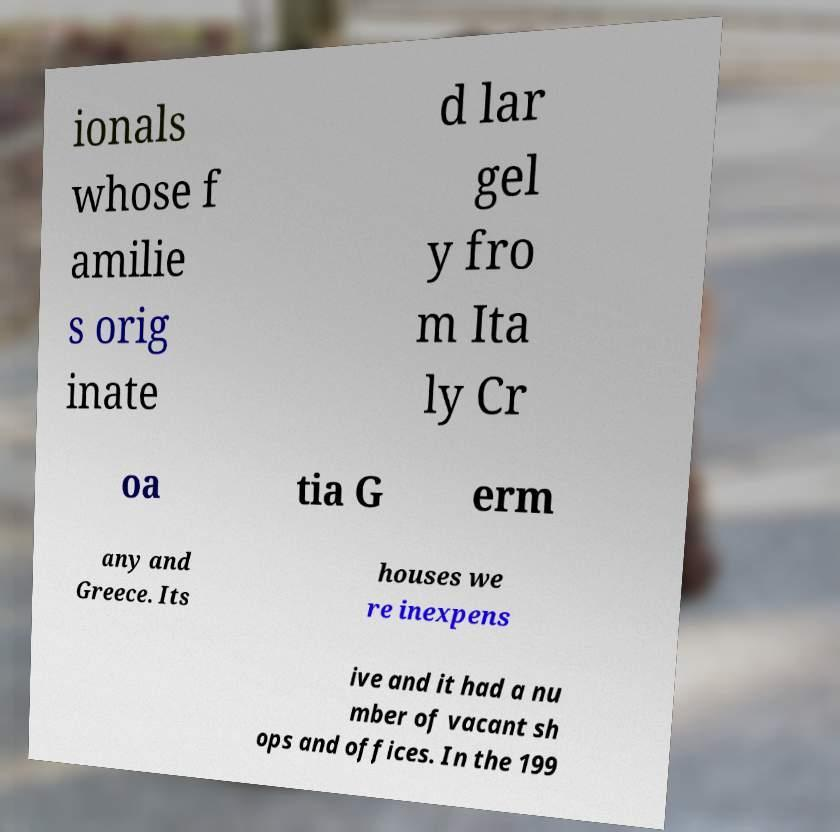Can you read and provide the text displayed in the image?This photo seems to have some interesting text. Can you extract and type it out for me? ionals whose f amilie s orig inate d lar gel y fro m Ita ly Cr oa tia G erm any and Greece. Its houses we re inexpens ive and it had a nu mber of vacant sh ops and offices. In the 199 